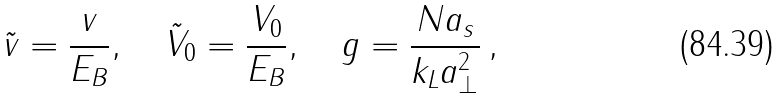Convert formula to latex. <formula><loc_0><loc_0><loc_500><loc_500>\tilde { v } = \frac { v } { E _ { B } } , \quad \tilde { V } _ { 0 } = \frac { V _ { 0 } } { E _ { B } } , \quad g = \frac { N a _ { s } } { k _ { L } a _ { \perp } ^ { 2 } } \, ,</formula> 